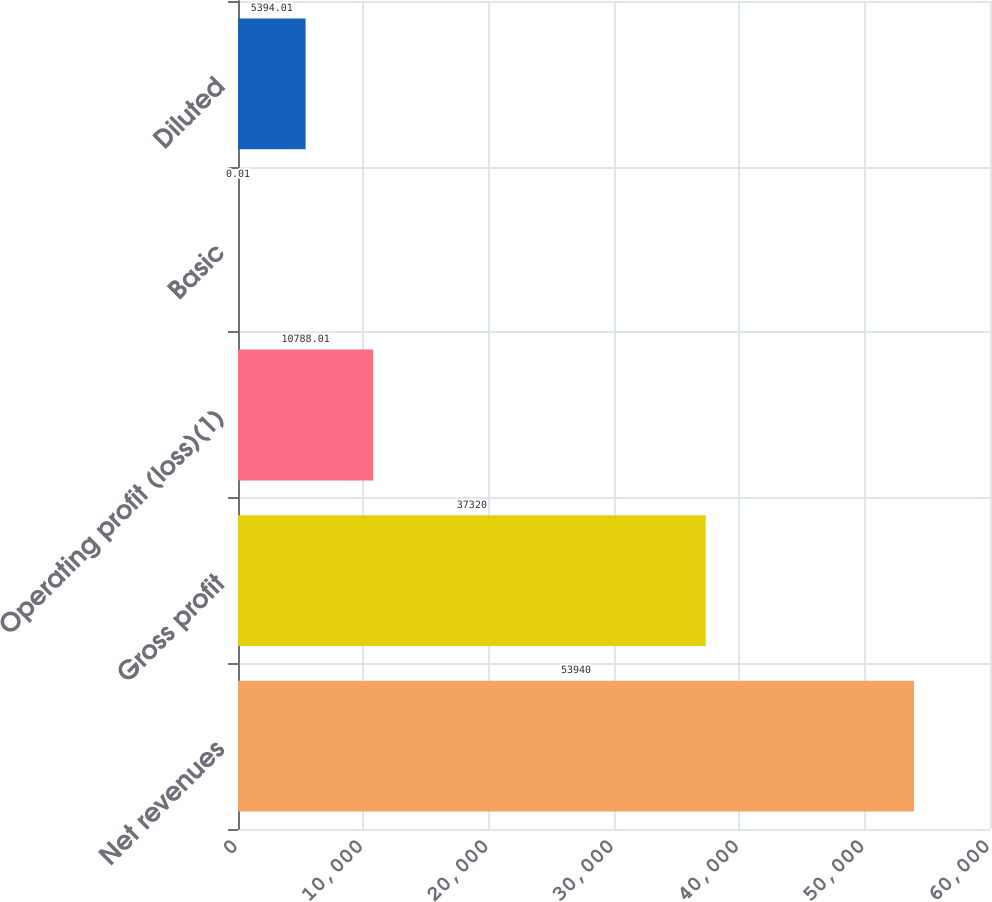Convert chart. <chart><loc_0><loc_0><loc_500><loc_500><bar_chart><fcel>Net revenues<fcel>Gross profit<fcel>Operating profit (loss)(1)<fcel>Basic<fcel>Diluted<nl><fcel>53940<fcel>37320<fcel>10788<fcel>0.01<fcel>5394.01<nl></chart> 